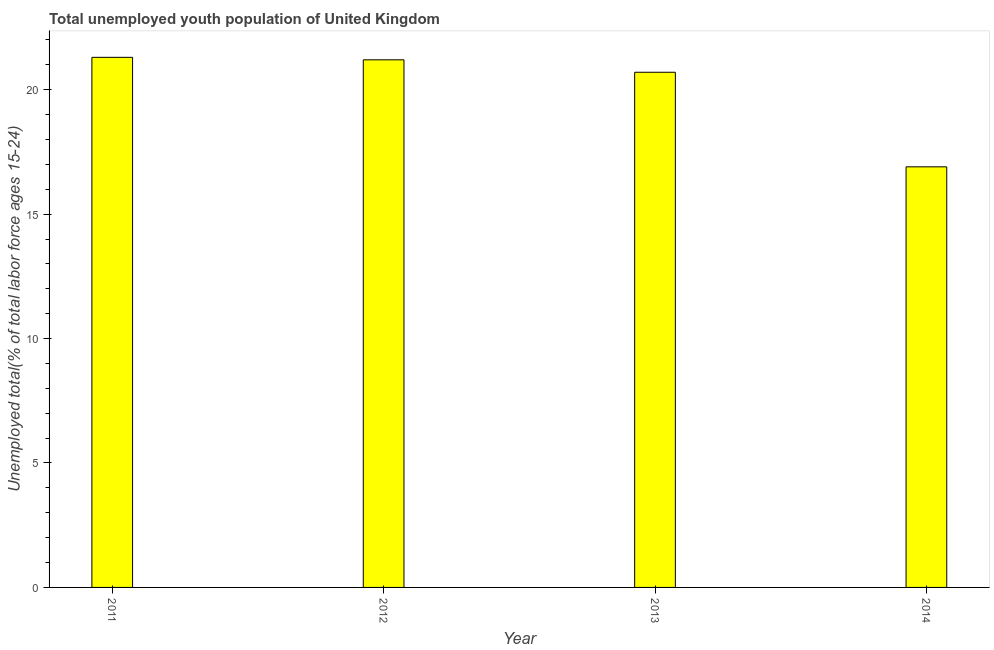Does the graph contain any zero values?
Keep it short and to the point. No. What is the title of the graph?
Give a very brief answer. Total unemployed youth population of United Kingdom. What is the label or title of the Y-axis?
Give a very brief answer. Unemployed total(% of total labor force ages 15-24). What is the unemployed youth in 2014?
Your answer should be very brief. 16.9. Across all years, what is the maximum unemployed youth?
Give a very brief answer. 21.3. Across all years, what is the minimum unemployed youth?
Your answer should be compact. 16.9. In which year was the unemployed youth maximum?
Give a very brief answer. 2011. In which year was the unemployed youth minimum?
Keep it short and to the point. 2014. What is the sum of the unemployed youth?
Your answer should be very brief. 80.1. What is the difference between the unemployed youth in 2012 and 2014?
Your response must be concise. 4.3. What is the average unemployed youth per year?
Keep it short and to the point. 20.02. What is the median unemployed youth?
Your answer should be very brief. 20.95. Do a majority of the years between 2014 and 2012 (inclusive) have unemployed youth greater than 12 %?
Your answer should be compact. Yes. In how many years, is the unemployed youth greater than the average unemployed youth taken over all years?
Make the answer very short. 3. What is the difference between two consecutive major ticks on the Y-axis?
Offer a very short reply. 5. What is the Unemployed total(% of total labor force ages 15-24) in 2011?
Provide a succinct answer. 21.3. What is the Unemployed total(% of total labor force ages 15-24) of 2012?
Make the answer very short. 21.2. What is the Unemployed total(% of total labor force ages 15-24) in 2013?
Make the answer very short. 20.7. What is the Unemployed total(% of total labor force ages 15-24) of 2014?
Your answer should be compact. 16.9. What is the difference between the Unemployed total(% of total labor force ages 15-24) in 2011 and 2014?
Provide a short and direct response. 4.4. What is the difference between the Unemployed total(% of total labor force ages 15-24) in 2012 and 2014?
Your response must be concise. 4.3. What is the ratio of the Unemployed total(% of total labor force ages 15-24) in 2011 to that in 2012?
Your answer should be very brief. 1. What is the ratio of the Unemployed total(% of total labor force ages 15-24) in 2011 to that in 2013?
Provide a short and direct response. 1.03. What is the ratio of the Unemployed total(% of total labor force ages 15-24) in 2011 to that in 2014?
Provide a short and direct response. 1.26. What is the ratio of the Unemployed total(% of total labor force ages 15-24) in 2012 to that in 2013?
Offer a terse response. 1.02. What is the ratio of the Unemployed total(% of total labor force ages 15-24) in 2012 to that in 2014?
Provide a succinct answer. 1.25. What is the ratio of the Unemployed total(% of total labor force ages 15-24) in 2013 to that in 2014?
Offer a very short reply. 1.23. 